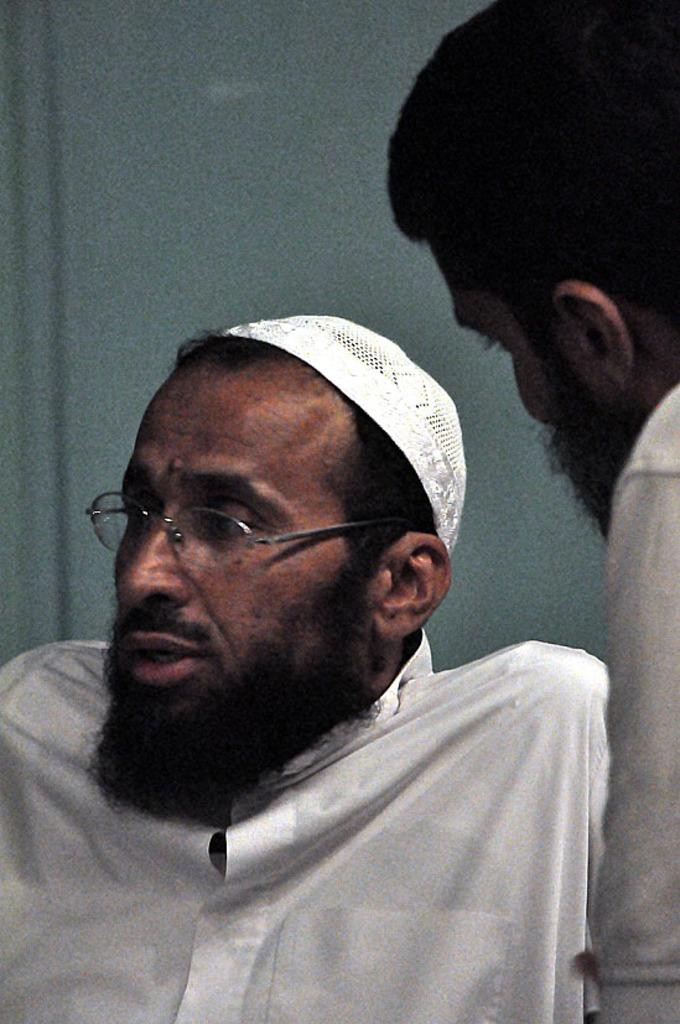What is the person in the image wearing? The person is wearing a white dress and a white cap in the image. Can you describe any facial features of the person? Yes, the person has a beard. Is there anyone else in the image? Yes, there is another person beside the first person in the right corner of the image. Can you tell me how many kitties are playing with the camera in the image? There are no kitties or cameras present in the image. Is the person's friend visible in the image? The provided facts do not mention a friend, so we cannot determine if the person's friend is visible in the image. 